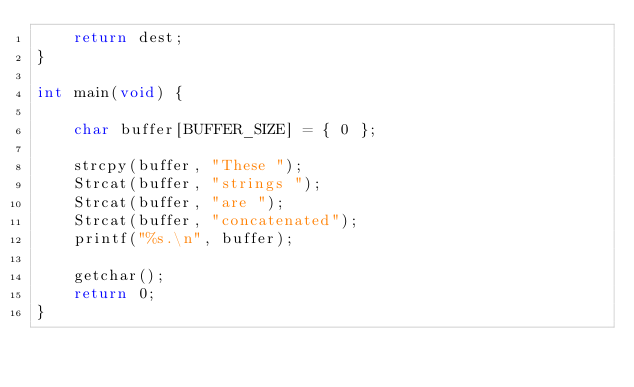<code> <loc_0><loc_0><loc_500><loc_500><_C_>    return dest;
}

int main(void) {    

    char buffer[BUFFER_SIZE] = { 0 };

    strcpy(buffer, "These ");
    Strcat(buffer, "strings ");
    Strcat(buffer, "are ");
    Strcat(buffer, "concatenated");
    printf("%s.\n", buffer);

    getchar();
    return 0;
}
</code> 